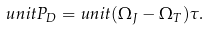<formula> <loc_0><loc_0><loc_500><loc_500>\ u n i t { P _ { D } } = & \ u n i t { ( \Omega _ { J } - \Omega _ { T } ) \tau } .</formula> 